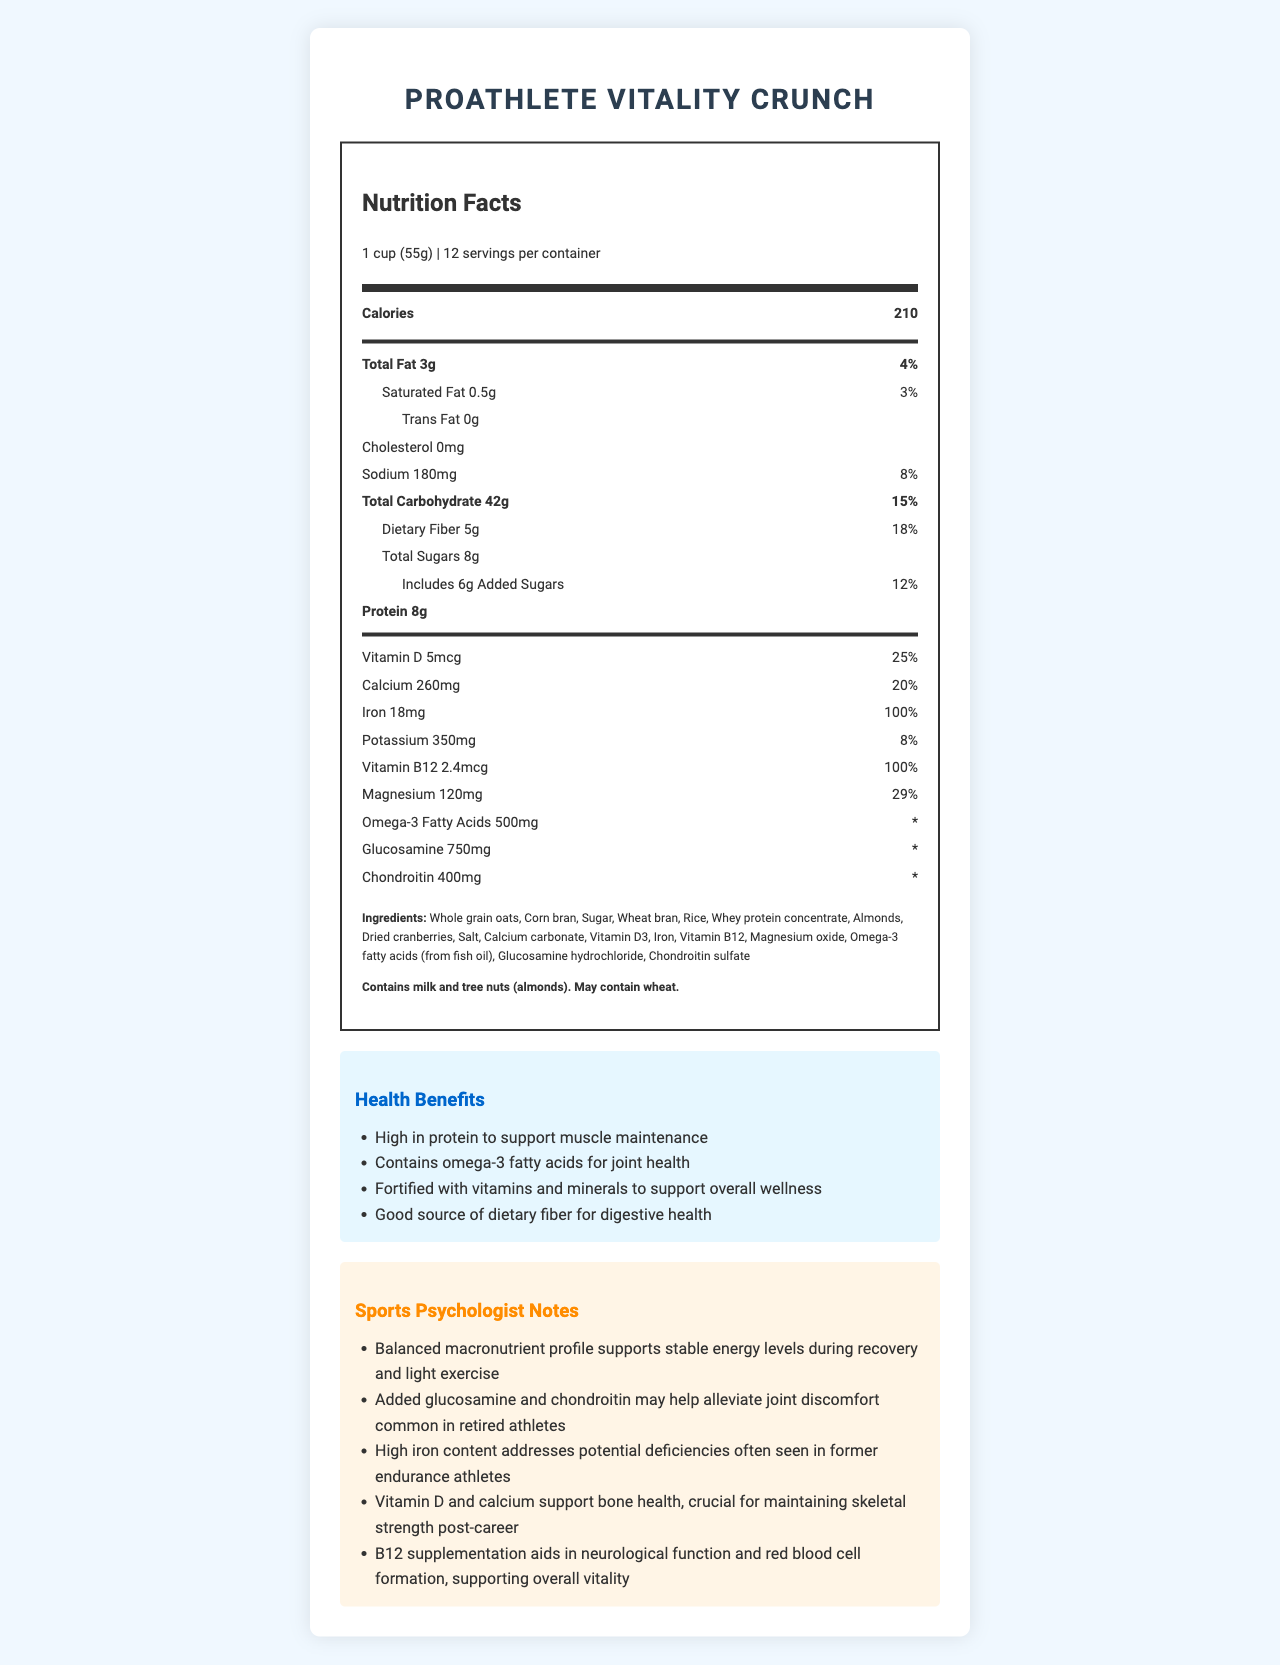what is the serving size of ProAthlete Vitality Crunch? The document specifies that the serving size is "1 cup (55g)" under the Nutrition Facts section.
Answer: 1 cup (55g) how many calories are in one serving? The document lists "Calories" as 210 in the Nutrition Facts section for one serving.
Answer: 210 What percentage of the daily value for dietary fiber does one serving provide? The Nutrition Facts section shows "Dietary Fiber" with a daily value of 18%.
Answer: 18% how much protein is in each serving? The Nutrition Facts section specifies that each serving contains "Protein 8g".
Answer: 8g Name one ingredient in this cereal that may contain allergens. The document mentions "Almonds" in the list of ingredients and specifies that it contains tree nuts in the allergen information.
Answer: Almonds Which vitamins and minerals are present in 100% of the daily value per serving? A. Vitamin D, Calcium B. Iron, Vitamin B12 C. Potassium, Magnesium The vitamins and minerals section indicates that Iron (18mg) and Vitamin B12 (2.4mcg) each provide 100% of the daily value.
Answer: B Which of the following is true regarding the health benefits of this cereal? A. Contains high sugar content B. Lacks fiber content C. Supports bone health The health claims section mentions that the cereal is fortified with vitamins and minerals including Vitamin D and calcium to support bone health.
Answer: C is this cereal suitable for someone with a tree nut allergy? The allergen information states that the cereal contains tree nuts (almonds).
Answer: No Summarize the main idea of the document. This cereal provides balanced macronutrients, high protein, and essential vitamins and minerals to support muscle maintenance, joint health, bone health, and overall wellness. It includes omega-3 fatty acids, glucosamine, and chondroitin for joint support and is high in iron, making it particularly suitable for retired endurance athletes. The document highlights the ingredients, nutritional content, health benefits, and allergen information for this product.
Answer: ProAthlete Vitality Crunch is a vitamin-fortified cereal designed to meet the nutritional needs of former professional athletes. How does the cereal support joint health according to the document? The health claims section mentions that omega-3 fatty acids support joint health, and the added glucosamine and chondroitin are cited in the sports psychologist notes to help alleviate joint discomfort.
Answer: Through omega-3 fatty acids, glucosamine, and chondroitin What ingredient in the cereal contributes to the high iron content? The ingredients list specifically includes "Iron" among the components, contributing to its high iron content for potential deficiencies in former endurance athletes.
Answer: Iron Explain the significance of magnesium in this cereal. The Nutrition Facts show that magnesium is present at 29% of the daily value, which is essential for muscle and nerve function, contributing to the overall health benefits of the cereal.
Answer: Supports muscle and nerve function which mineral is present in the highest amount relative to daily value?  A. Iron B. Calcium C. Potassium D. Magnesium According to the Nutrition Facts, Iron is present at 100% of the daily value, the highest compared to calcium (20%), potassium (8%), and magnesium (29%).
Answer: A Which of the following ingredients is not mentioned in the allergen information? A. Almonds B. Milk C. Wheat D. Soy The allergen information states that the cereal contains milk and tree nuts (almonds) and may contain wheat, but does not mention soy.
Answer: D What advice would you give to an athlete looking to maintain skeletal strength after retirement? The sports psychologist notes that Vitamin D and calcium support bone health, which is crucial for maintaining skeletal strength post-career.
Answer: Include products rich in Vitamin D and calcium how many grams of total carbohydrates are in two servings of the cereal? One serving contains 42g of total carbohydrates, so two servings would be 42g x 2 = 84g.
Answer: 84g Does the document provide a sugar breakdown? The Nutrition Facts show total sugars as 8g and added sugars as 6g, thus providing a breakdown of sugar content.
Answer: Yes What specific needs of former endurance athletes does this cereal address? The sports psychologist notes mention the high iron content addresses potential deficiencies often seen in former endurance athletes.
Answer: High iron content Does this cereal contain trans fat? The Nutrition Facts section lists "Trans Fat 0g".
Answer: No Can we determine if this cereal is gluten-free based on the document? The document lists "Wheat bran" among its ingredients and mentions that it may contain wheat, but it doesn't provide a clear indication if it is gluten-free or certified as such.
Answer: Not enough information 